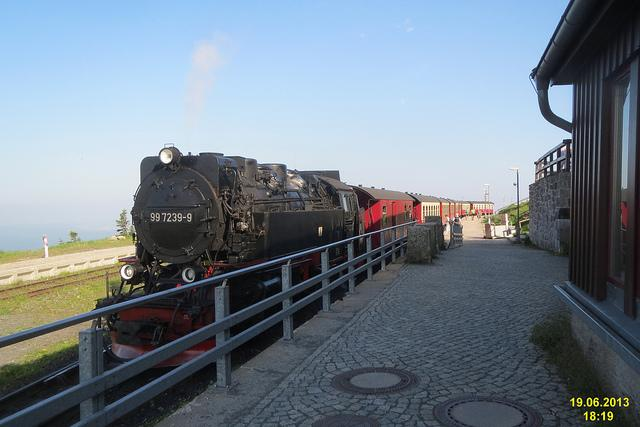Where might someone buy a ticket for this train?

Choices:
A) online
B) newsboy
C) inside building
D) train inside building 